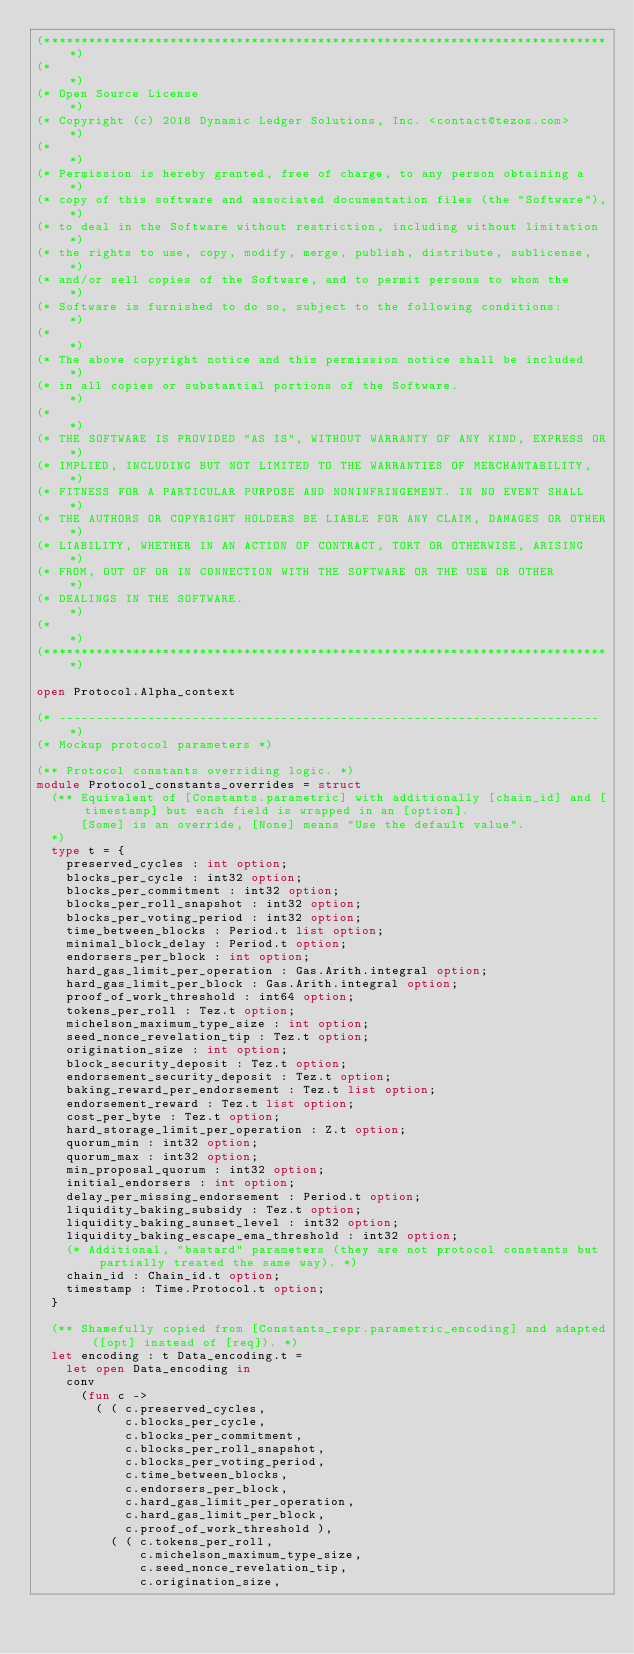Convert code to text. <code><loc_0><loc_0><loc_500><loc_500><_OCaml_>(*****************************************************************************)
(*                                                                           *)
(* Open Source License                                                       *)
(* Copyright (c) 2018 Dynamic Ledger Solutions, Inc. <contact@tezos.com>     *)
(*                                                                           *)
(* Permission is hereby granted, free of charge, to any person obtaining a   *)
(* copy of this software and associated documentation files (the "Software"),*)
(* to deal in the Software without restriction, including without limitation *)
(* the rights to use, copy, modify, merge, publish, distribute, sublicense,  *)
(* and/or sell copies of the Software, and to permit persons to whom the     *)
(* Software is furnished to do so, subject to the following conditions:      *)
(*                                                                           *)
(* The above copyright notice and this permission notice shall be included   *)
(* in all copies or substantial portions of the Software.                    *)
(*                                                                           *)
(* THE SOFTWARE IS PROVIDED "AS IS", WITHOUT WARRANTY OF ANY KIND, EXPRESS OR*)
(* IMPLIED, INCLUDING BUT NOT LIMITED TO THE WARRANTIES OF MERCHANTABILITY,  *)
(* FITNESS FOR A PARTICULAR PURPOSE AND NONINFRINGEMENT. IN NO EVENT SHALL   *)
(* THE AUTHORS OR COPYRIGHT HOLDERS BE LIABLE FOR ANY CLAIM, DAMAGES OR OTHER*)
(* LIABILITY, WHETHER IN AN ACTION OF CONTRACT, TORT OR OTHERWISE, ARISING   *)
(* FROM, OUT OF OR IN CONNECTION WITH THE SOFTWARE OR THE USE OR OTHER       *)
(* DEALINGS IN THE SOFTWARE.                                                 *)
(*                                                                           *)
(*****************************************************************************)

open Protocol.Alpha_context

(* ------------------------------------------------------------------------- *)
(* Mockup protocol parameters *)

(** Protocol constants overriding logic. *)
module Protocol_constants_overrides = struct
  (** Equivalent of [Constants.parametric] with additionally [chain_id] and [timestamp] but each field is wrapped in an [option].
      [Some] is an override, [None] means "Use the default value".
  *)
  type t = {
    preserved_cycles : int option;
    blocks_per_cycle : int32 option;
    blocks_per_commitment : int32 option;
    blocks_per_roll_snapshot : int32 option;
    blocks_per_voting_period : int32 option;
    time_between_blocks : Period.t list option;
    minimal_block_delay : Period.t option;
    endorsers_per_block : int option;
    hard_gas_limit_per_operation : Gas.Arith.integral option;
    hard_gas_limit_per_block : Gas.Arith.integral option;
    proof_of_work_threshold : int64 option;
    tokens_per_roll : Tez.t option;
    michelson_maximum_type_size : int option;
    seed_nonce_revelation_tip : Tez.t option;
    origination_size : int option;
    block_security_deposit : Tez.t option;
    endorsement_security_deposit : Tez.t option;
    baking_reward_per_endorsement : Tez.t list option;
    endorsement_reward : Tez.t list option;
    cost_per_byte : Tez.t option;
    hard_storage_limit_per_operation : Z.t option;
    quorum_min : int32 option;
    quorum_max : int32 option;
    min_proposal_quorum : int32 option;
    initial_endorsers : int option;
    delay_per_missing_endorsement : Period.t option;
    liquidity_baking_subsidy : Tez.t option;
    liquidity_baking_sunset_level : int32 option;
    liquidity_baking_escape_ema_threshold : int32 option;
    (* Additional, "bastard" parameters (they are not protocol constants but partially treated the same way). *)
    chain_id : Chain_id.t option;
    timestamp : Time.Protocol.t option;
  }

  (** Shamefully copied from [Constants_repr.parametric_encoding] and adapted ([opt] instead of [req]). *)
  let encoding : t Data_encoding.t =
    let open Data_encoding in
    conv
      (fun c ->
        ( ( c.preserved_cycles,
            c.blocks_per_cycle,
            c.blocks_per_commitment,
            c.blocks_per_roll_snapshot,
            c.blocks_per_voting_period,
            c.time_between_blocks,
            c.endorsers_per_block,
            c.hard_gas_limit_per_operation,
            c.hard_gas_limit_per_block,
            c.proof_of_work_threshold ),
          ( ( c.tokens_per_roll,
              c.michelson_maximum_type_size,
              c.seed_nonce_revelation_tip,
              c.origination_size,</code> 